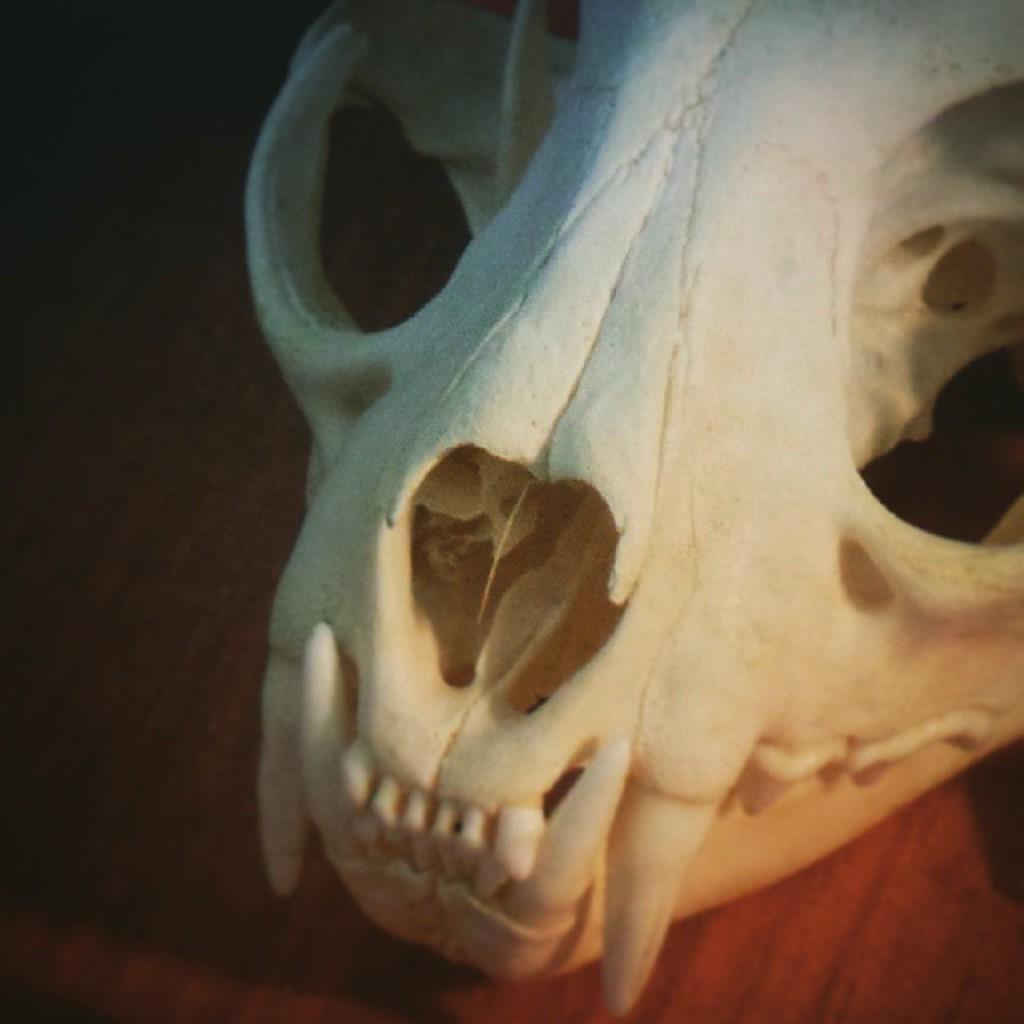What is the main subject of the image? The main subject of the image is a skull. What type of skull is depicted in the image? The skull belongs to an animal. Where is the skull located in the image? The skull is placed on a table. How many divisions are present in the crib in the image? There is no crib present in the image; it features a skull placed on a table. 